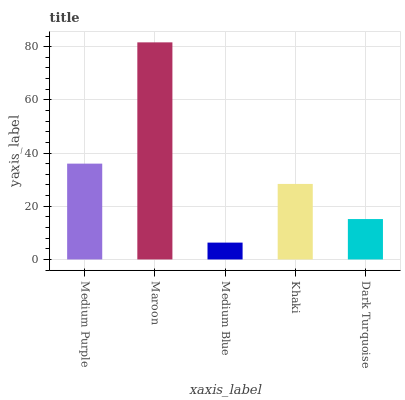Is Medium Blue the minimum?
Answer yes or no. Yes. Is Maroon the maximum?
Answer yes or no. Yes. Is Maroon the minimum?
Answer yes or no. No. Is Medium Blue the maximum?
Answer yes or no. No. Is Maroon greater than Medium Blue?
Answer yes or no. Yes. Is Medium Blue less than Maroon?
Answer yes or no. Yes. Is Medium Blue greater than Maroon?
Answer yes or no. No. Is Maroon less than Medium Blue?
Answer yes or no. No. Is Khaki the high median?
Answer yes or no. Yes. Is Khaki the low median?
Answer yes or no. Yes. Is Medium Blue the high median?
Answer yes or no. No. Is Medium Blue the low median?
Answer yes or no. No. 